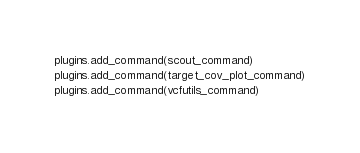Convert code to text. <code><loc_0><loc_0><loc_500><loc_500><_Python_>

plugins.add_command(scout_command)
plugins.add_command(target_cov_plot_command)
plugins.add_command(vcfutils_command)
</code> 